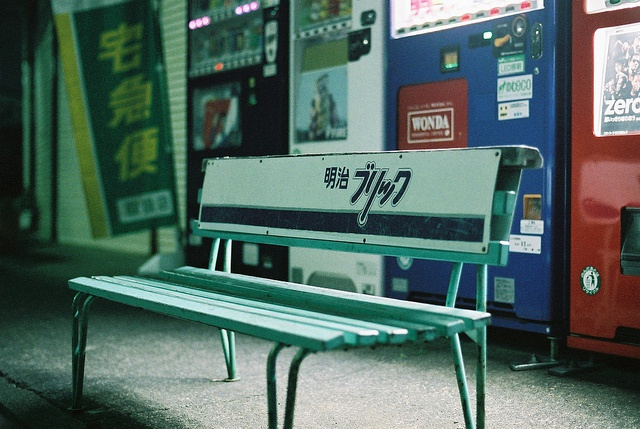Describe the objects in this image and their specific colors. I can see a bench in black, darkgray, and teal tones in this image. 